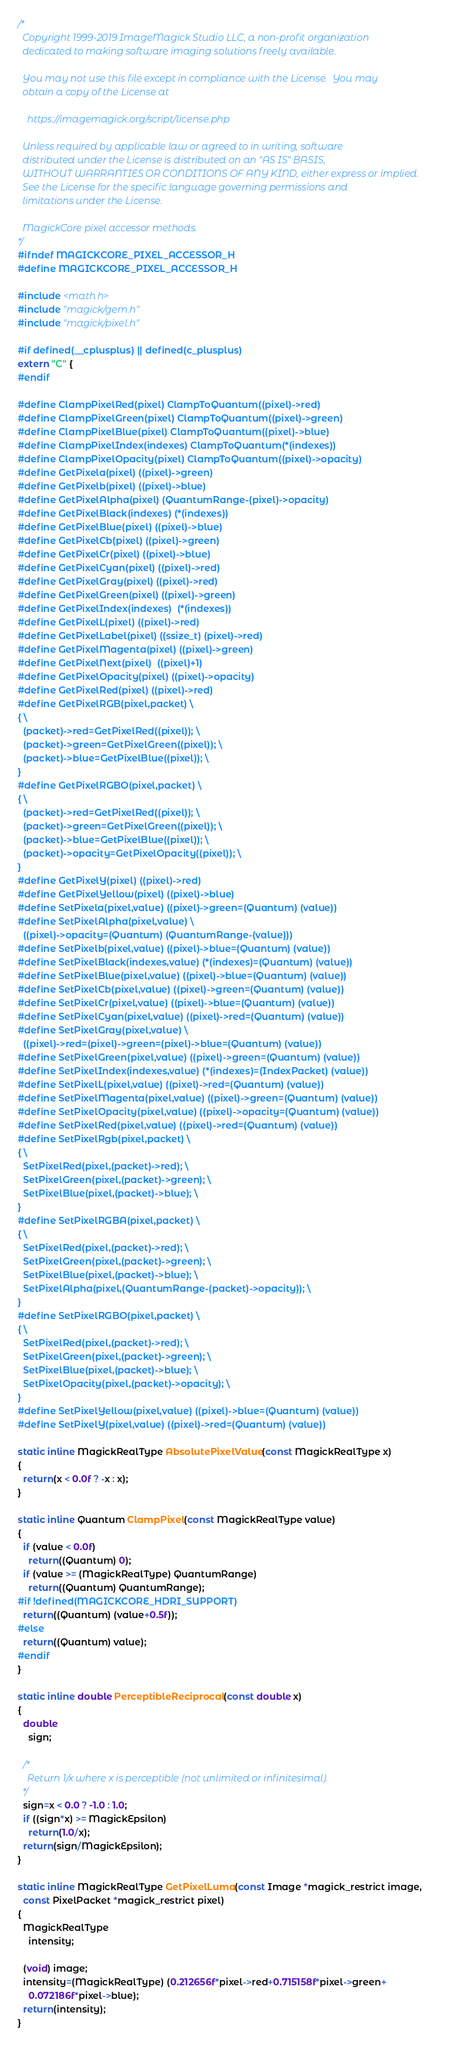Convert code to text. <code><loc_0><loc_0><loc_500><loc_500><_C_>/*
  Copyright 1999-2019 ImageMagick Studio LLC, a non-profit organization
  dedicated to making software imaging solutions freely available.

  You may not use this file except in compliance with the License.  You may
  obtain a copy of the License at

    https://imagemagick.org/script/license.php

  Unless required by applicable law or agreed to in writing, software
  distributed under the License is distributed on an "AS IS" BASIS,
  WITHOUT WARRANTIES OR CONDITIONS OF ANY KIND, either express or implied.
  See the License for the specific language governing permissions and
  limitations under the License.

  MagickCore pixel accessor methods.
*/
#ifndef MAGICKCORE_PIXEL_ACCESSOR_H
#define MAGICKCORE_PIXEL_ACCESSOR_H

#include <math.h>
#include "magick/gem.h"
#include "magick/pixel.h"

#if defined(__cplusplus) || defined(c_plusplus)
extern "C" {
#endif

#define ClampPixelRed(pixel) ClampToQuantum((pixel)->red)
#define ClampPixelGreen(pixel) ClampToQuantum((pixel)->green)
#define ClampPixelBlue(pixel) ClampToQuantum((pixel)->blue)
#define ClampPixelIndex(indexes) ClampToQuantum(*(indexes))
#define ClampPixelOpacity(pixel) ClampToQuantum((pixel)->opacity)
#define GetPixela(pixel) ((pixel)->green)
#define GetPixelb(pixel) ((pixel)->blue)
#define GetPixelAlpha(pixel) (QuantumRange-(pixel)->opacity)
#define GetPixelBlack(indexes) (*(indexes))
#define GetPixelBlue(pixel) ((pixel)->blue)
#define GetPixelCb(pixel) ((pixel)->green)
#define GetPixelCr(pixel) ((pixel)->blue)
#define GetPixelCyan(pixel) ((pixel)->red)
#define GetPixelGray(pixel) ((pixel)->red)
#define GetPixelGreen(pixel) ((pixel)->green)
#define GetPixelIndex(indexes)  (*(indexes))
#define GetPixelL(pixel) ((pixel)->red)
#define GetPixelLabel(pixel) ((ssize_t) (pixel)->red)
#define GetPixelMagenta(pixel) ((pixel)->green)
#define GetPixelNext(pixel)  ((pixel)+1)
#define GetPixelOpacity(pixel) ((pixel)->opacity)
#define GetPixelRed(pixel) ((pixel)->red)
#define GetPixelRGB(pixel,packet) \
{ \
  (packet)->red=GetPixelRed((pixel)); \
  (packet)->green=GetPixelGreen((pixel)); \
  (packet)->blue=GetPixelBlue((pixel)); \
}
#define GetPixelRGBO(pixel,packet) \
{ \
  (packet)->red=GetPixelRed((pixel)); \
  (packet)->green=GetPixelGreen((pixel)); \
  (packet)->blue=GetPixelBlue((pixel)); \
  (packet)->opacity=GetPixelOpacity((pixel)); \
}
#define GetPixelY(pixel) ((pixel)->red)
#define GetPixelYellow(pixel) ((pixel)->blue)
#define SetPixela(pixel,value) ((pixel)->green=(Quantum) (value))
#define SetPixelAlpha(pixel,value) \
  ((pixel)->opacity=(Quantum) (QuantumRange-(value)))
#define SetPixelb(pixel,value) ((pixel)->blue=(Quantum) (value))
#define SetPixelBlack(indexes,value) (*(indexes)=(Quantum) (value))
#define SetPixelBlue(pixel,value) ((pixel)->blue=(Quantum) (value))
#define SetPixelCb(pixel,value) ((pixel)->green=(Quantum) (value))
#define SetPixelCr(pixel,value) ((pixel)->blue=(Quantum) (value))
#define SetPixelCyan(pixel,value) ((pixel)->red=(Quantum) (value))
#define SetPixelGray(pixel,value) \
  ((pixel)->red=(pixel)->green=(pixel)->blue=(Quantum) (value))
#define SetPixelGreen(pixel,value) ((pixel)->green=(Quantum) (value))
#define SetPixelIndex(indexes,value) (*(indexes)=(IndexPacket) (value))
#define SetPixelL(pixel,value) ((pixel)->red=(Quantum) (value))
#define SetPixelMagenta(pixel,value) ((pixel)->green=(Quantum) (value))
#define SetPixelOpacity(pixel,value) ((pixel)->opacity=(Quantum) (value))
#define SetPixelRed(pixel,value) ((pixel)->red=(Quantum) (value))
#define SetPixelRgb(pixel,packet) \
{ \
  SetPixelRed(pixel,(packet)->red); \
  SetPixelGreen(pixel,(packet)->green); \
  SetPixelBlue(pixel,(packet)->blue); \
}
#define SetPixelRGBA(pixel,packet) \
{ \
  SetPixelRed(pixel,(packet)->red); \
  SetPixelGreen(pixel,(packet)->green); \
  SetPixelBlue(pixel,(packet)->blue); \
  SetPixelAlpha(pixel,(QuantumRange-(packet)->opacity)); \
}
#define SetPixelRGBO(pixel,packet) \
{ \
  SetPixelRed(pixel,(packet)->red); \
  SetPixelGreen(pixel,(packet)->green); \
  SetPixelBlue(pixel,(packet)->blue); \
  SetPixelOpacity(pixel,(packet)->opacity); \
}
#define SetPixelYellow(pixel,value) ((pixel)->blue=(Quantum) (value))
#define SetPixelY(pixel,value) ((pixel)->red=(Quantum) (value))

static inline MagickRealType AbsolutePixelValue(const MagickRealType x)
{
  return(x < 0.0f ? -x : x);
}

static inline Quantum ClampPixel(const MagickRealType value)
{ 
  if (value < 0.0f)
    return((Quantum) 0); 
  if (value >= (MagickRealType) QuantumRange)
    return((Quantum) QuantumRange);
#if !defined(MAGICKCORE_HDRI_SUPPORT)
  return((Quantum) (value+0.5f));
#else
  return((Quantum) value);
#endif
}

static inline double PerceptibleReciprocal(const double x)
{ 
  double
    sign;
      
  /*
    Return 1/x where x is perceptible (not unlimited or infinitesimal).
  */
  sign=x < 0.0 ? -1.0 : 1.0;
  if ((sign*x) >= MagickEpsilon)
    return(1.0/x);
  return(sign/MagickEpsilon);
}   

static inline MagickRealType GetPixelLuma(const Image *magick_restrict image,
  const PixelPacket *magick_restrict pixel)
{
  MagickRealType
    intensity;

  (void) image;
  intensity=(MagickRealType) (0.212656f*pixel->red+0.715158f*pixel->green+
    0.072186f*pixel->blue);
  return(intensity);
}
</code> 